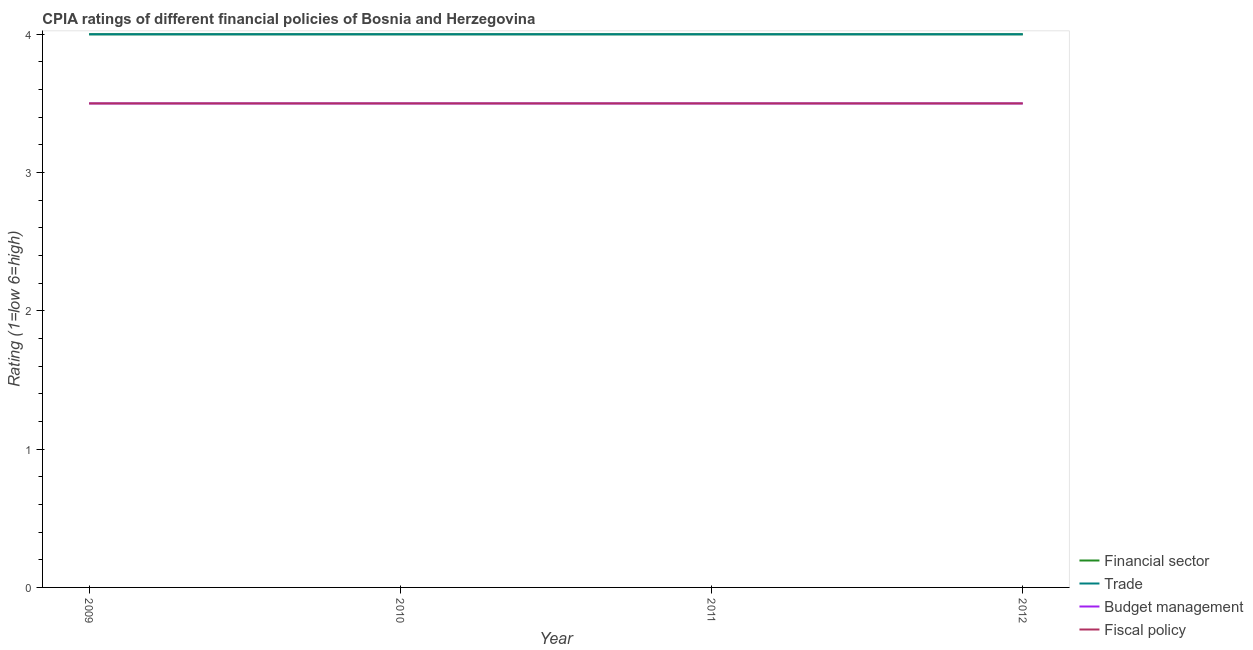How many different coloured lines are there?
Offer a very short reply. 4. Does the line corresponding to cpia rating of fiscal policy intersect with the line corresponding to cpia rating of financial sector?
Provide a short and direct response. No. Is the number of lines equal to the number of legend labels?
Ensure brevity in your answer.  Yes. Across all years, what is the maximum cpia rating of budget management?
Keep it short and to the point. 3.5. What is the difference between the cpia rating of financial sector in 2011 and the cpia rating of budget management in 2009?
Provide a succinct answer. 0.5. What is the average cpia rating of trade per year?
Keep it short and to the point. 4. In the year 2009, what is the difference between the cpia rating of trade and cpia rating of fiscal policy?
Your answer should be very brief. 0.5. In how many years, is the cpia rating of fiscal policy greater than 0.2?
Make the answer very short. 4. What is the ratio of the cpia rating of trade in 2011 to that in 2012?
Your answer should be compact. 1. Is the sum of the cpia rating of fiscal policy in 2009 and 2010 greater than the maximum cpia rating of budget management across all years?
Your answer should be very brief. Yes. Is it the case that in every year, the sum of the cpia rating of financial sector and cpia rating of trade is greater than the cpia rating of budget management?
Ensure brevity in your answer.  Yes. Is the cpia rating of fiscal policy strictly greater than the cpia rating of trade over the years?
Provide a short and direct response. No. How many lines are there?
Make the answer very short. 4. How many years are there in the graph?
Your answer should be very brief. 4. Are the values on the major ticks of Y-axis written in scientific E-notation?
Your answer should be very brief. No. How are the legend labels stacked?
Ensure brevity in your answer.  Vertical. What is the title of the graph?
Provide a short and direct response. CPIA ratings of different financial policies of Bosnia and Herzegovina. What is the label or title of the Y-axis?
Offer a terse response. Rating (1=low 6=high). What is the Rating (1=low 6=high) of Financial sector in 2009?
Offer a terse response. 4. What is the Rating (1=low 6=high) in Budget management in 2009?
Offer a terse response. 3.5. What is the Rating (1=low 6=high) in Fiscal policy in 2009?
Provide a short and direct response. 3.5. What is the Rating (1=low 6=high) in Financial sector in 2010?
Your response must be concise. 4. What is the Rating (1=low 6=high) in Fiscal policy in 2010?
Ensure brevity in your answer.  3.5. What is the Rating (1=low 6=high) of Financial sector in 2011?
Offer a terse response. 4. What is the Rating (1=low 6=high) of Trade in 2011?
Ensure brevity in your answer.  4. What is the Rating (1=low 6=high) in Budget management in 2011?
Keep it short and to the point. 3.5. What is the Rating (1=low 6=high) of Fiscal policy in 2011?
Provide a short and direct response. 3.5. What is the Rating (1=low 6=high) in Fiscal policy in 2012?
Your answer should be very brief. 3.5. Across all years, what is the maximum Rating (1=low 6=high) in Trade?
Provide a succinct answer. 4. Across all years, what is the maximum Rating (1=low 6=high) of Budget management?
Your answer should be compact. 3.5. Across all years, what is the minimum Rating (1=low 6=high) in Trade?
Your answer should be very brief. 4. Across all years, what is the minimum Rating (1=low 6=high) in Budget management?
Your answer should be compact. 3.5. What is the total Rating (1=low 6=high) in Financial sector in the graph?
Provide a short and direct response. 16. What is the total Rating (1=low 6=high) in Trade in the graph?
Keep it short and to the point. 16. What is the total Rating (1=low 6=high) in Fiscal policy in the graph?
Your response must be concise. 14. What is the difference between the Rating (1=low 6=high) in Trade in 2009 and that in 2010?
Your answer should be very brief. 0. What is the difference between the Rating (1=low 6=high) in Fiscal policy in 2009 and that in 2010?
Your answer should be very brief. 0. What is the difference between the Rating (1=low 6=high) of Financial sector in 2009 and that in 2011?
Your response must be concise. 0. What is the difference between the Rating (1=low 6=high) of Trade in 2009 and that in 2011?
Make the answer very short. 0. What is the difference between the Rating (1=low 6=high) of Budget management in 2009 and that in 2011?
Provide a succinct answer. 0. What is the difference between the Rating (1=low 6=high) in Financial sector in 2009 and that in 2012?
Provide a short and direct response. 0. What is the difference between the Rating (1=low 6=high) in Trade in 2010 and that in 2011?
Offer a terse response. 0. What is the difference between the Rating (1=low 6=high) of Budget management in 2010 and that in 2011?
Make the answer very short. 0. What is the difference between the Rating (1=low 6=high) in Fiscal policy in 2010 and that in 2011?
Your answer should be compact. 0. What is the difference between the Rating (1=low 6=high) of Trade in 2010 and that in 2012?
Make the answer very short. 0. What is the difference between the Rating (1=low 6=high) of Fiscal policy in 2010 and that in 2012?
Provide a succinct answer. 0. What is the difference between the Rating (1=low 6=high) of Budget management in 2011 and that in 2012?
Provide a short and direct response. 0. What is the difference between the Rating (1=low 6=high) of Fiscal policy in 2011 and that in 2012?
Offer a very short reply. 0. What is the difference between the Rating (1=low 6=high) of Financial sector in 2009 and the Rating (1=low 6=high) of Fiscal policy in 2010?
Provide a succinct answer. 0.5. What is the difference between the Rating (1=low 6=high) of Trade in 2009 and the Rating (1=low 6=high) of Budget management in 2010?
Offer a terse response. 0.5. What is the difference between the Rating (1=low 6=high) in Trade in 2009 and the Rating (1=low 6=high) in Fiscal policy in 2010?
Ensure brevity in your answer.  0.5. What is the difference between the Rating (1=low 6=high) of Budget management in 2009 and the Rating (1=low 6=high) of Fiscal policy in 2010?
Ensure brevity in your answer.  0. What is the difference between the Rating (1=low 6=high) in Financial sector in 2009 and the Rating (1=low 6=high) in Trade in 2011?
Provide a succinct answer. 0. What is the difference between the Rating (1=low 6=high) of Financial sector in 2009 and the Rating (1=low 6=high) of Budget management in 2011?
Offer a terse response. 0.5. What is the difference between the Rating (1=low 6=high) of Financial sector in 2009 and the Rating (1=low 6=high) of Fiscal policy in 2011?
Keep it short and to the point. 0.5. What is the difference between the Rating (1=low 6=high) in Trade in 2009 and the Rating (1=low 6=high) in Budget management in 2011?
Offer a very short reply. 0.5. What is the difference between the Rating (1=low 6=high) of Trade in 2009 and the Rating (1=low 6=high) of Fiscal policy in 2011?
Keep it short and to the point. 0.5. What is the difference between the Rating (1=low 6=high) in Budget management in 2009 and the Rating (1=low 6=high) in Fiscal policy in 2011?
Keep it short and to the point. 0. What is the difference between the Rating (1=low 6=high) in Trade in 2009 and the Rating (1=low 6=high) in Fiscal policy in 2012?
Offer a very short reply. 0.5. What is the difference between the Rating (1=low 6=high) in Financial sector in 2010 and the Rating (1=low 6=high) in Budget management in 2011?
Offer a terse response. 0.5. What is the difference between the Rating (1=low 6=high) in Trade in 2010 and the Rating (1=low 6=high) in Budget management in 2011?
Make the answer very short. 0.5. What is the difference between the Rating (1=low 6=high) in Trade in 2010 and the Rating (1=low 6=high) in Fiscal policy in 2011?
Give a very brief answer. 0.5. What is the difference between the Rating (1=low 6=high) in Financial sector in 2010 and the Rating (1=low 6=high) in Budget management in 2012?
Your answer should be very brief. 0.5. What is the difference between the Rating (1=low 6=high) of Trade in 2010 and the Rating (1=low 6=high) of Fiscal policy in 2012?
Ensure brevity in your answer.  0.5. What is the difference between the Rating (1=low 6=high) in Budget management in 2010 and the Rating (1=low 6=high) in Fiscal policy in 2012?
Ensure brevity in your answer.  0. What is the difference between the Rating (1=low 6=high) of Financial sector in 2011 and the Rating (1=low 6=high) of Trade in 2012?
Give a very brief answer. 0. What is the difference between the Rating (1=low 6=high) in Financial sector in 2011 and the Rating (1=low 6=high) in Fiscal policy in 2012?
Offer a very short reply. 0.5. What is the difference between the Rating (1=low 6=high) in Trade in 2011 and the Rating (1=low 6=high) in Fiscal policy in 2012?
Offer a very short reply. 0.5. What is the average Rating (1=low 6=high) of Trade per year?
Provide a succinct answer. 4. In the year 2009, what is the difference between the Rating (1=low 6=high) in Financial sector and Rating (1=low 6=high) in Trade?
Give a very brief answer. 0. In the year 2009, what is the difference between the Rating (1=low 6=high) in Trade and Rating (1=low 6=high) in Budget management?
Give a very brief answer. 0.5. In the year 2009, what is the difference between the Rating (1=low 6=high) in Trade and Rating (1=low 6=high) in Fiscal policy?
Provide a succinct answer. 0.5. In the year 2010, what is the difference between the Rating (1=low 6=high) in Financial sector and Rating (1=low 6=high) in Budget management?
Offer a terse response. 0.5. In the year 2010, what is the difference between the Rating (1=low 6=high) in Financial sector and Rating (1=low 6=high) in Fiscal policy?
Offer a terse response. 0.5. In the year 2010, what is the difference between the Rating (1=low 6=high) in Trade and Rating (1=low 6=high) in Budget management?
Keep it short and to the point. 0.5. In the year 2011, what is the difference between the Rating (1=low 6=high) of Financial sector and Rating (1=low 6=high) of Trade?
Make the answer very short. 0. In the year 2011, what is the difference between the Rating (1=low 6=high) of Financial sector and Rating (1=low 6=high) of Budget management?
Your answer should be very brief. 0.5. In the year 2011, what is the difference between the Rating (1=low 6=high) of Financial sector and Rating (1=low 6=high) of Fiscal policy?
Give a very brief answer. 0.5. In the year 2011, what is the difference between the Rating (1=low 6=high) of Budget management and Rating (1=low 6=high) of Fiscal policy?
Keep it short and to the point. 0. In the year 2012, what is the difference between the Rating (1=low 6=high) in Trade and Rating (1=low 6=high) in Budget management?
Ensure brevity in your answer.  0.5. In the year 2012, what is the difference between the Rating (1=low 6=high) in Budget management and Rating (1=low 6=high) in Fiscal policy?
Ensure brevity in your answer.  0. What is the ratio of the Rating (1=low 6=high) in Financial sector in 2009 to that in 2010?
Offer a very short reply. 1. What is the ratio of the Rating (1=low 6=high) in Trade in 2009 to that in 2011?
Provide a short and direct response. 1. What is the ratio of the Rating (1=low 6=high) of Trade in 2009 to that in 2012?
Offer a terse response. 1. What is the ratio of the Rating (1=low 6=high) of Budget management in 2009 to that in 2012?
Make the answer very short. 1. What is the ratio of the Rating (1=low 6=high) in Fiscal policy in 2009 to that in 2012?
Your answer should be compact. 1. What is the ratio of the Rating (1=low 6=high) of Financial sector in 2010 to that in 2011?
Keep it short and to the point. 1. What is the ratio of the Rating (1=low 6=high) of Trade in 2010 to that in 2011?
Your response must be concise. 1. What is the ratio of the Rating (1=low 6=high) in Financial sector in 2010 to that in 2012?
Provide a succinct answer. 1. What is the ratio of the Rating (1=low 6=high) of Budget management in 2010 to that in 2012?
Provide a short and direct response. 1. What is the ratio of the Rating (1=low 6=high) of Fiscal policy in 2010 to that in 2012?
Offer a terse response. 1. What is the difference between the highest and the second highest Rating (1=low 6=high) in Budget management?
Provide a short and direct response. 0. What is the difference between the highest and the second highest Rating (1=low 6=high) in Fiscal policy?
Provide a short and direct response. 0. What is the difference between the highest and the lowest Rating (1=low 6=high) of Financial sector?
Your answer should be compact. 0. What is the difference between the highest and the lowest Rating (1=low 6=high) of Trade?
Keep it short and to the point. 0. 